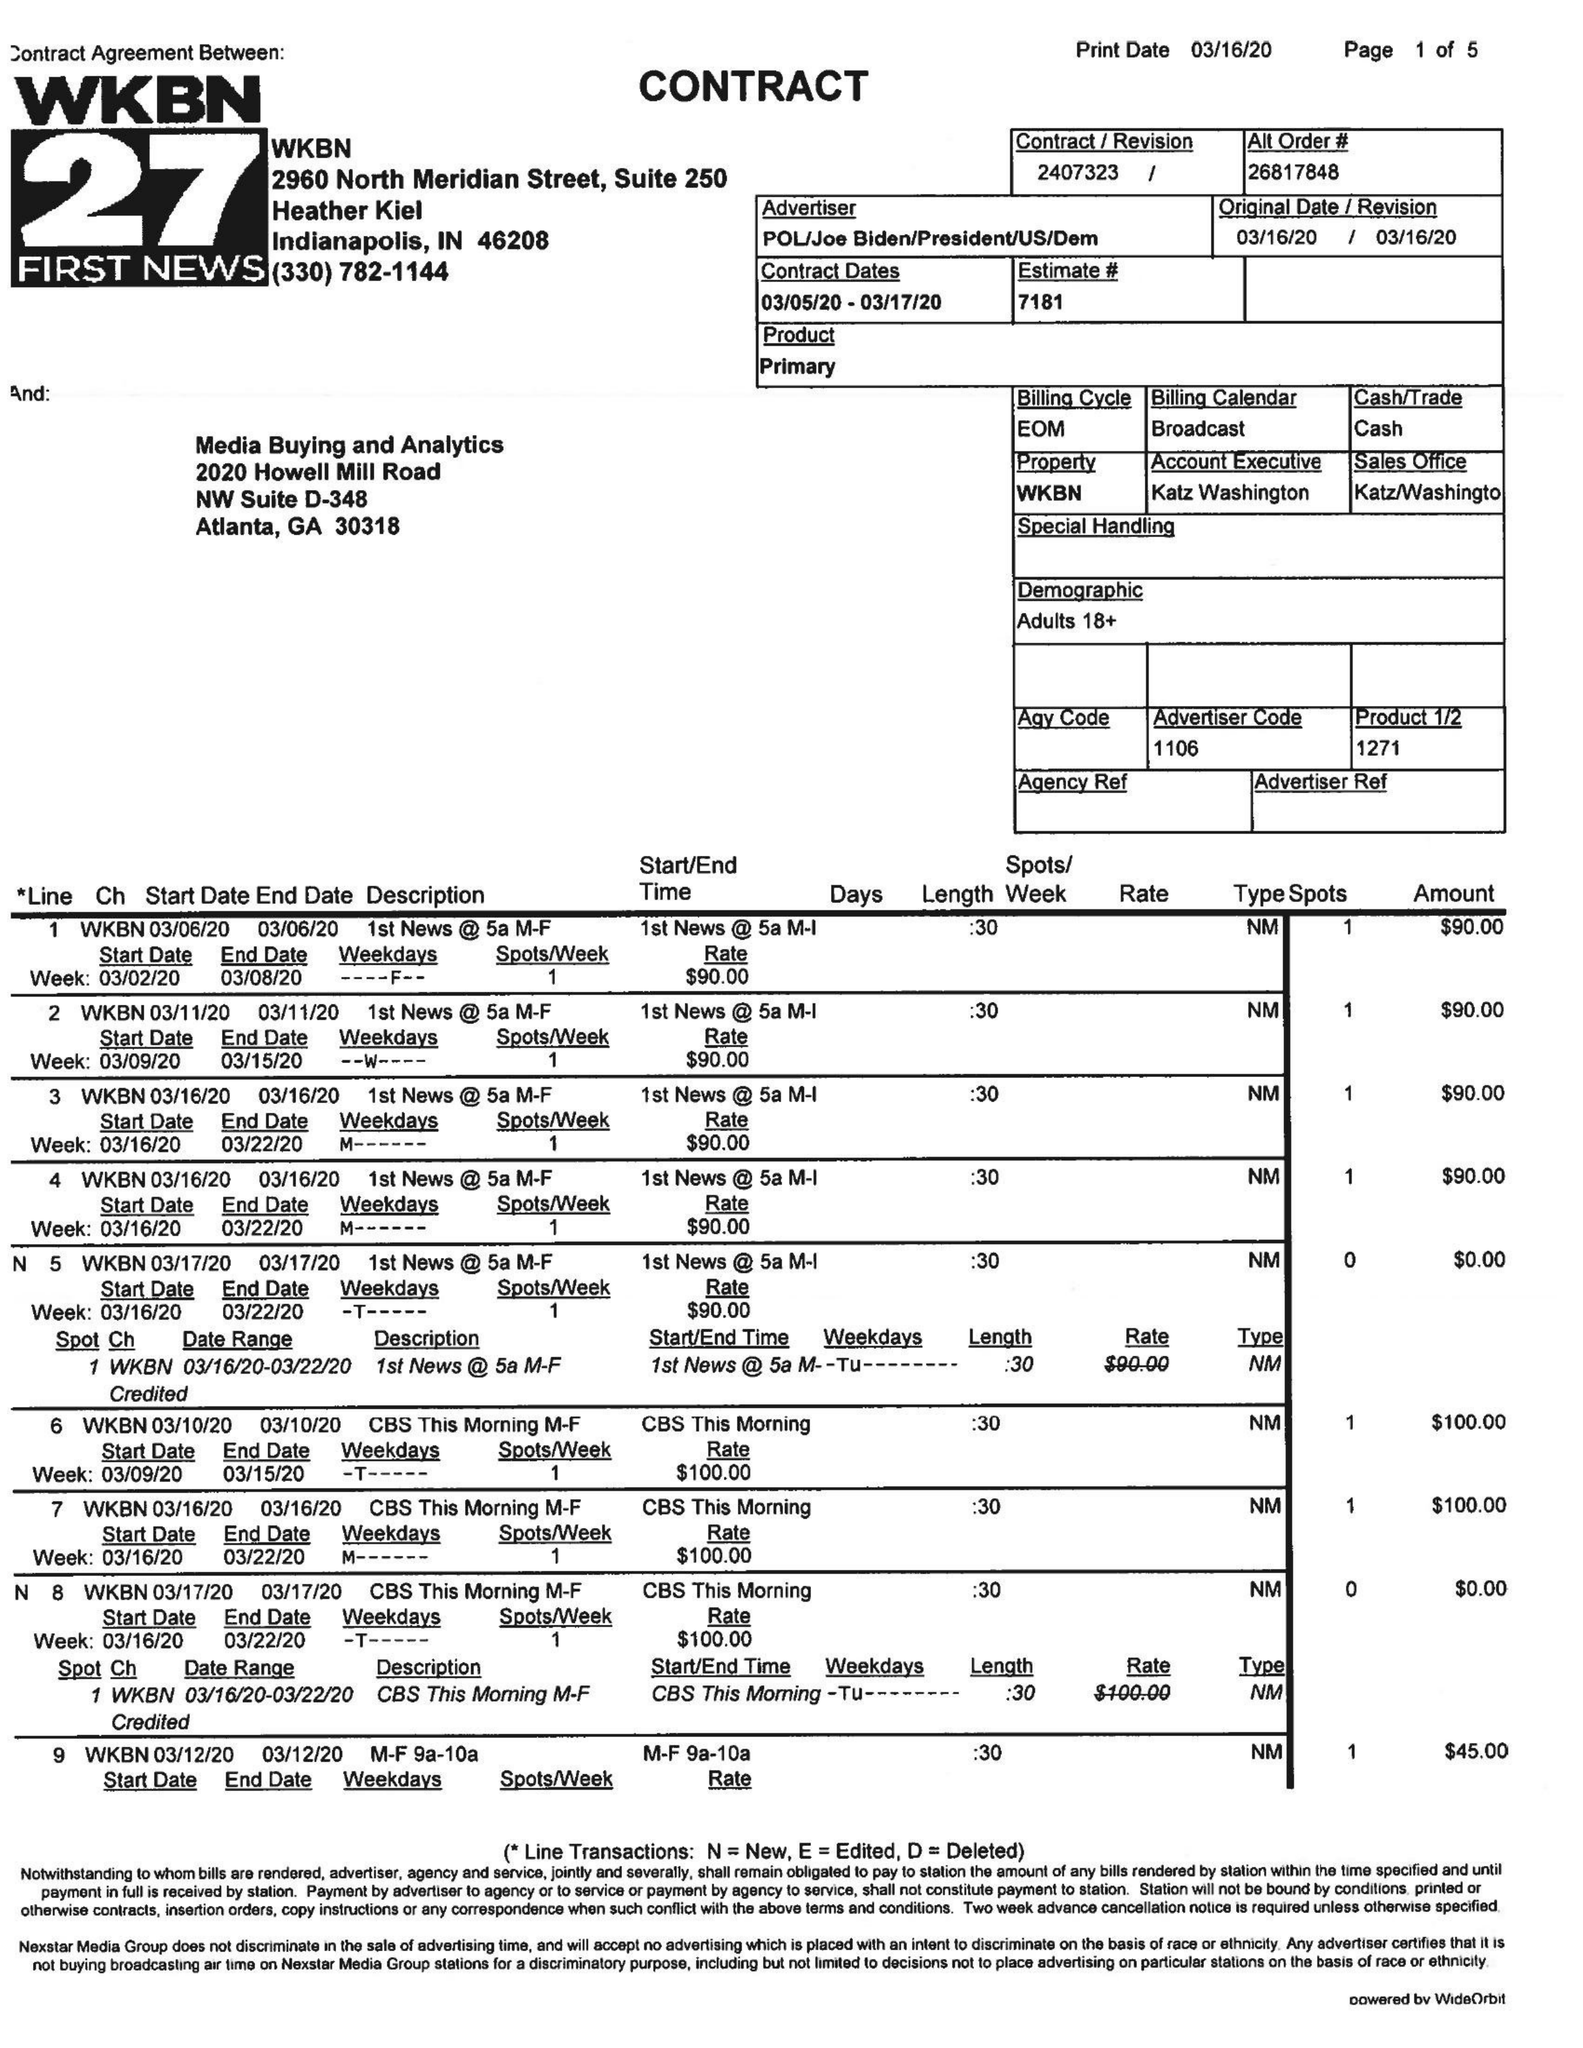What is the value for the contract_num?
Answer the question using a single word or phrase. 2407323 